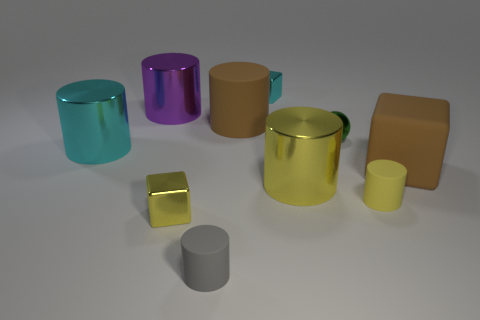There is a thing that is the same color as the big rubber block; what is its material?
Your answer should be compact. Rubber. Is there a large metallic cylinder that has the same color as the matte cube?
Keep it short and to the point. No. What is the shape of the cyan metallic thing that is the same size as the yellow metallic cylinder?
Your answer should be compact. Cylinder. There is a small cylinder that is right of the gray cylinder; what is its color?
Offer a terse response. Yellow. There is a brown thing in front of the small ball; is there a large brown matte block that is to the right of it?
Your response must be concise. No. What number of objects are tiny metal cubes in front of the green metal thing or yellow metallic things?
Provide a succinct answer. 2. Is there any other thing that has the same size as the purple metal cylinder?
Provide a succinct answer. Yes. What is the brown thing to the left of the big rubber object on the right side of the green metallic sphere made of?
Your answer should be compact. Rubber. Are there an equal number of brown blocks behind the green metallic ball and small objects that are to the left of the yellow rubber cylinder?
Keep it short and to the point. No. What number of objects are either small things in front of the yellow shiny block or big shiny cylinders to the right of the large cyan shiny thing?
Ensure brevity in your answer.  3. 